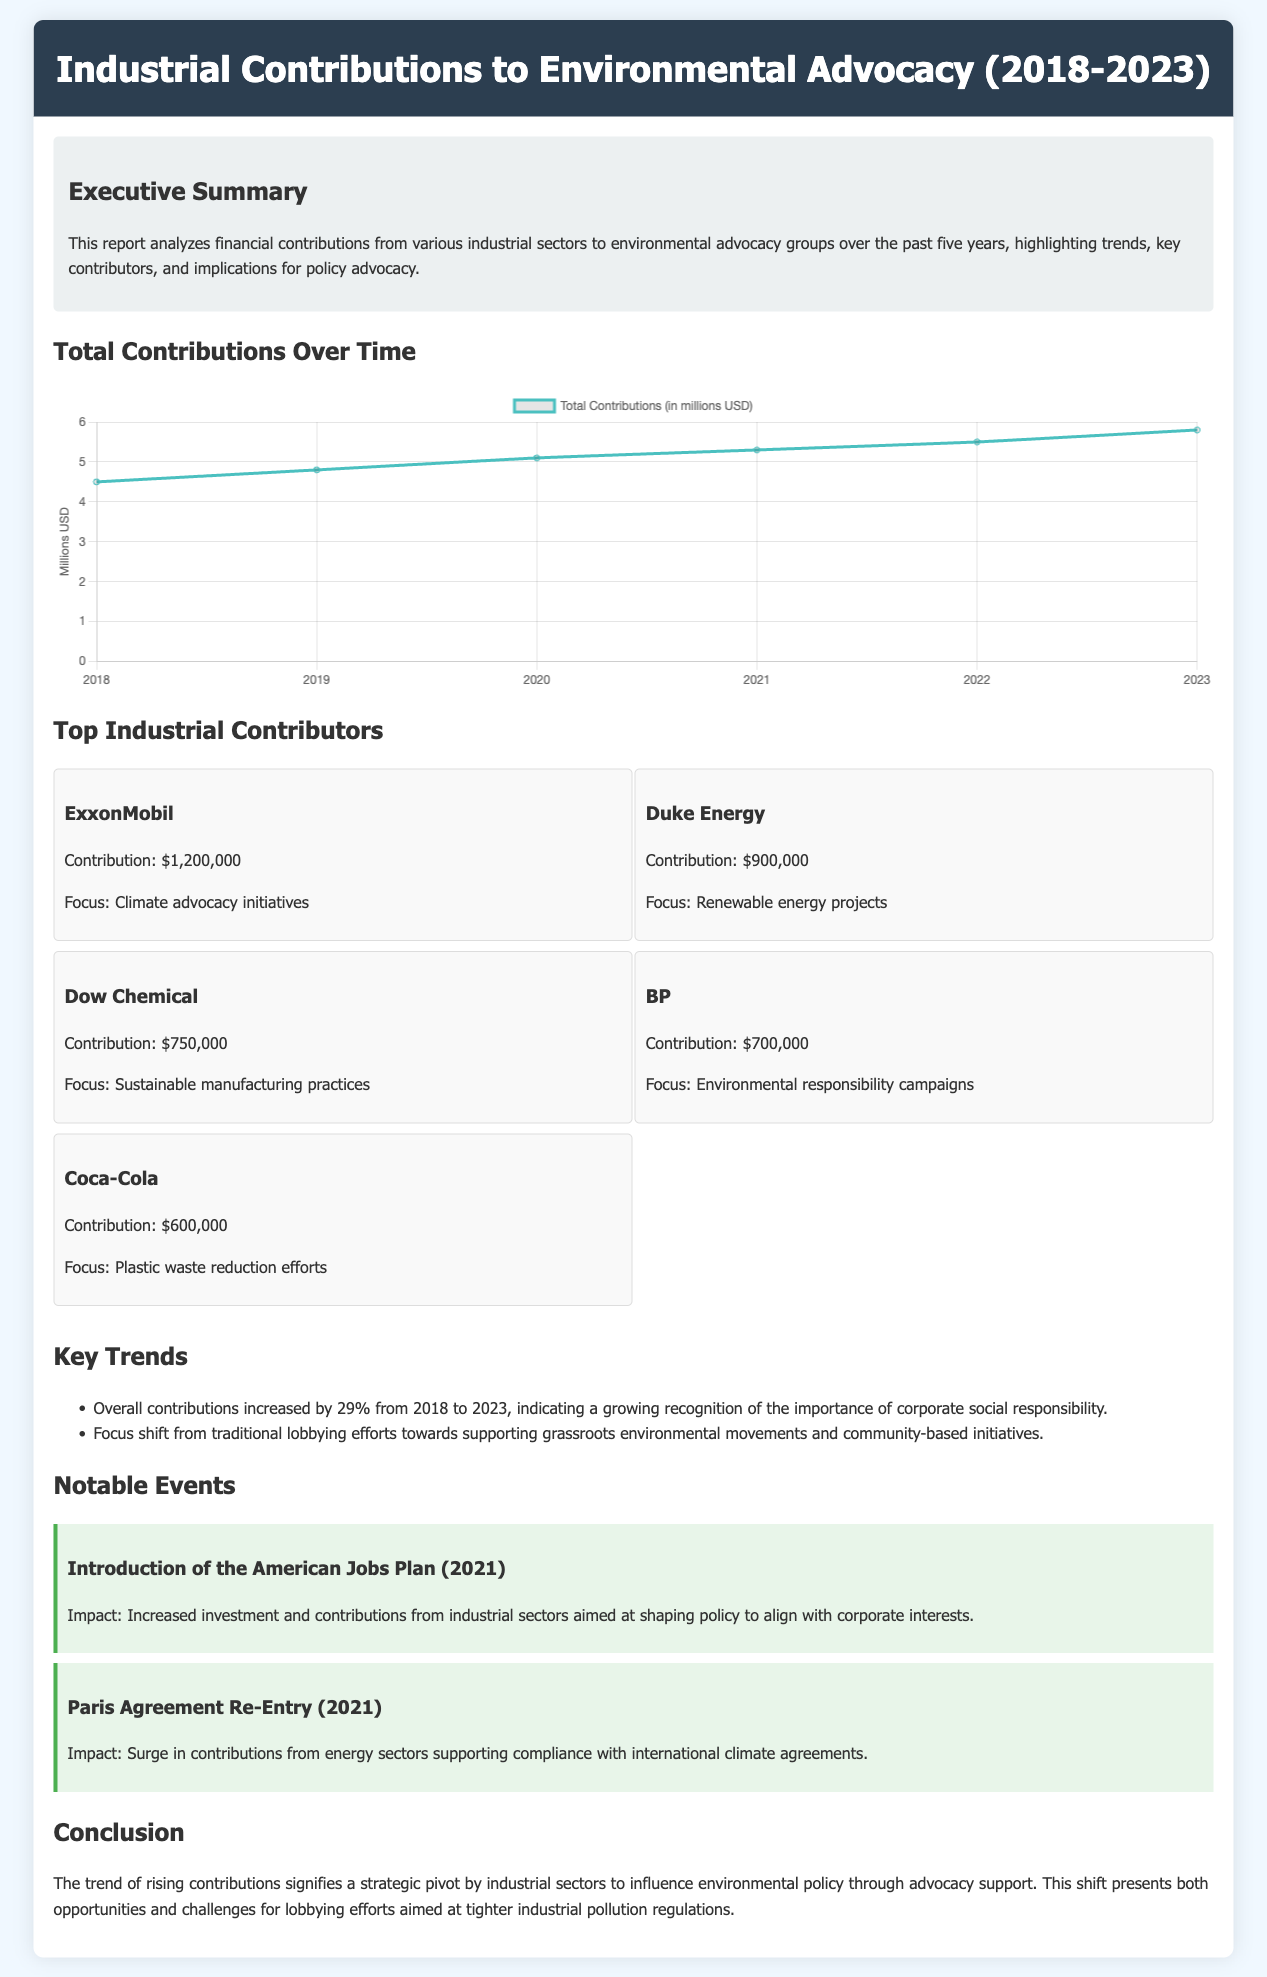What was the total contribution from ExxonMobil? The total contribution from ExxonMobil is specified in the top contributors section of the document.
Answer: $1,200,000 What year saw a total contribution amount of 5.1 million USD? The contributions for each year are listed in the trends section, identifying peak amounts for specific years.
Answer: 2020 Which company contributed the least? The document lists multiple companies with their contributions, allowing for comparison to find the minimum.
Answer: Coca-Cola What was the percentage increase in contributions from 2018 to 2023? The overall contributions over time are provided, showing the trend for this specific timeframe.
Answer: 29% Which notable event occurred in 2021, impacting industrial contributions? The notable events section provides details on significant occurrences that influenced contributions.
Answer: Introduction of the American Jobs Plan What was the focus of Duke Energy's contribution? Each contributor in the top contributors section has a specified focus area for their contributions.
Answer: Renewable energy projects What trend is observed regarding corporate contributions over the past five years? The key trends mentioned help in understanding the overall shift in corporate contributions.
Answer: Growing recognition of corporate social responsibility How many top contributors are listed in the document? The section on top industrial contributors specifically lists the number of contributors detailed.
Answer: Five What is the title of the report? The title of the report is given at the very beginning of the document, explicitly stating its focus.
Answer: Industrial Contributions to Environmental Advocacy (2018-2023) 